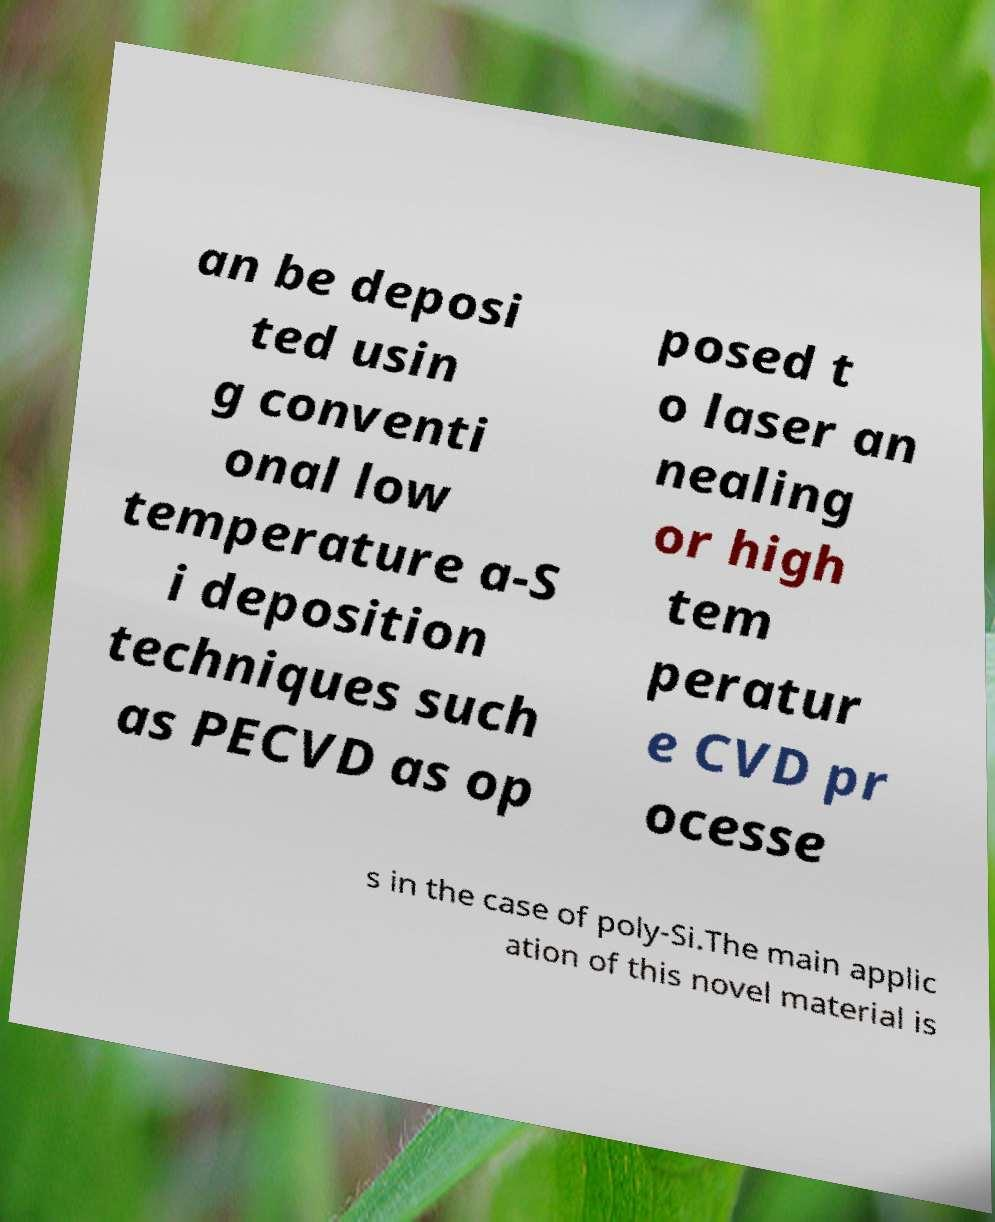Please identify and transcribe the text found in this image. an be deposi ted usin g conventi onal low temperature a-S i deposition techniques such as PECVD as op posed t o laser an nealing or high tem peratur e CVD pr ocesse s in the case of poly-Si.The main applic ation of this novel material is 